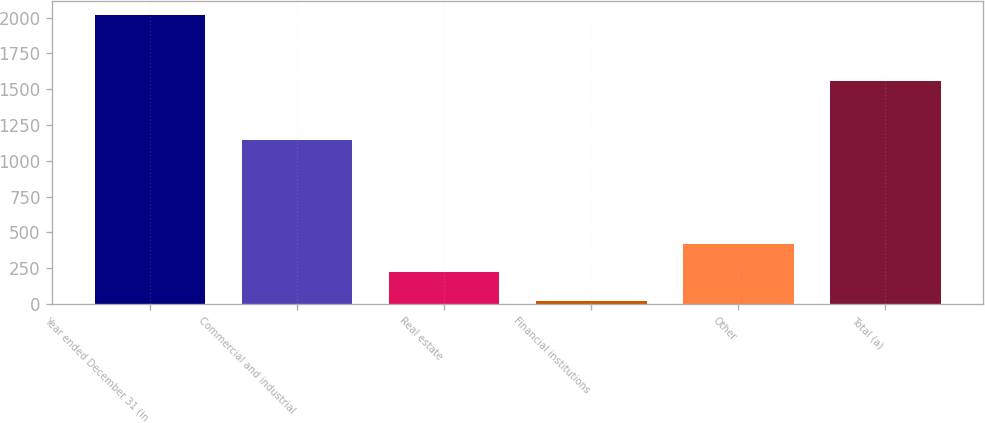Convert chart to OTSL. <chart><loc_0><loc_0><loc_500><loc_500><bar_chart><fcel>Year ended December 31 (in<fcel>Commercial and industrial<fcel>Real estate<fcel>Financial institutions<fcel>Other<fcel>Total (a)<nl><fcel>2017<fcel>1145<fcel>219.7<fcel>20<fcel>419.4<fcel>1560<nl></chart> 